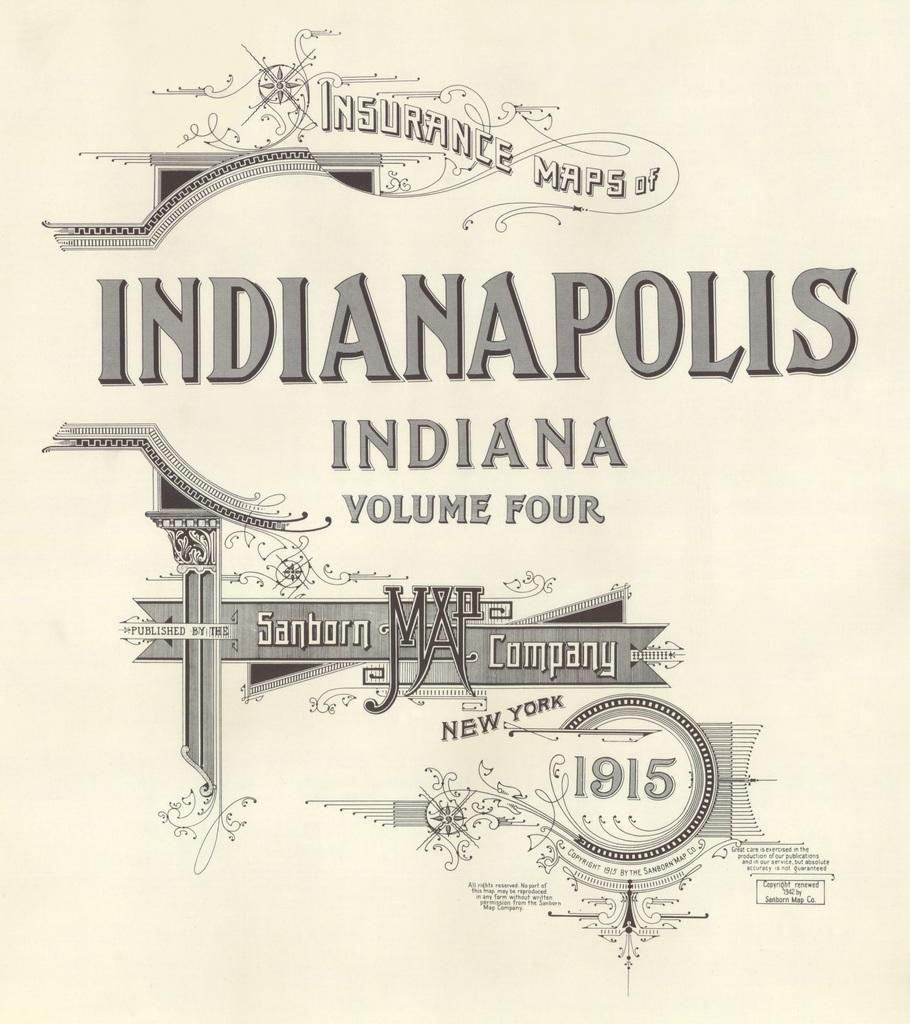<image>
Offer a succinct explanation of the picture presented. The cover of a book that is volume four about Indianapolis maps. 